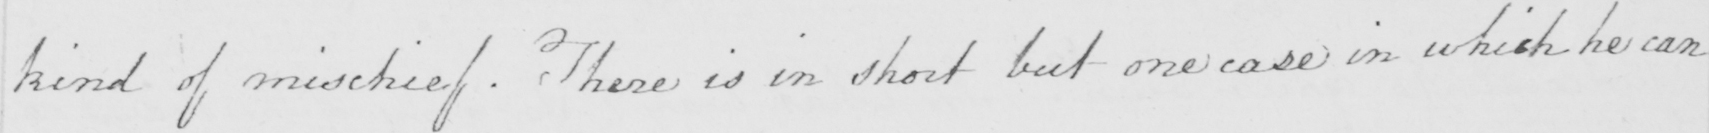What is written in this line of handwriting? kind of mischief . There is in short but one case in which he can 